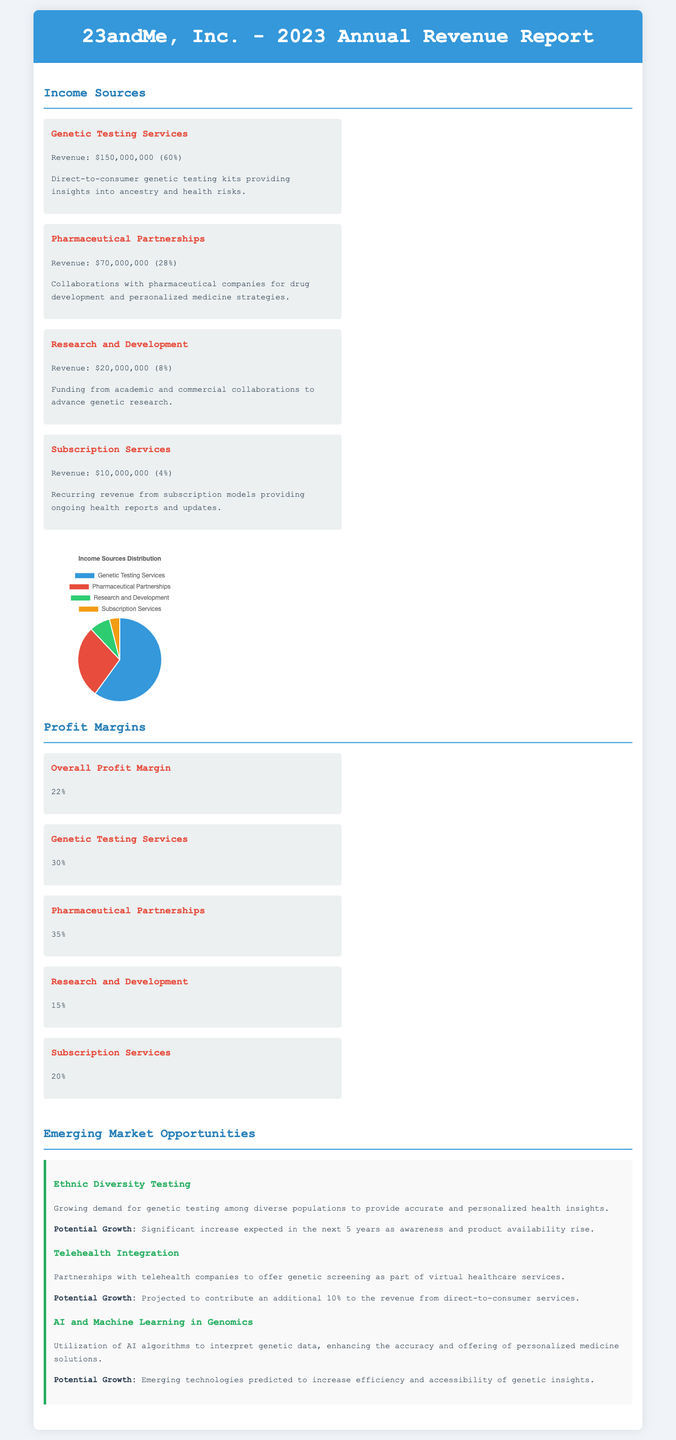what is the revenue from Genetic Testing Services? The revenue for Genetic Testing Services is explicitly stated in the document as $150,000,000.
Answer: $150,000,000 what percentage of the total revenue comes from Pharmaceutical Partnerships? The document specifies that Pharmaceutical Partnerships contribute 28% to the total revenue.
Answer: 28% what is the overall profit margin reported in the document? The overall profit margin is provided as 22%.
Answer: 22% which income source has the highest profit margin? The document states that Pharmaceutical Partnerships have the highest profit margin at 35%.
Answer: 35% what growth potential is mentioned for Telehealth Integration? The document indicates that Telehealth Integration is projected to contribute an additional 10% to the revenue from direct-to-consumer services.
Answer: 10% how much revenue does the Subscription Services generate? The revenue generated from Subscription Services is mentioned as $10,000,000.
Answer: $10,000,000 what emerging market opportunity involves AI and Machine Learning? The document discusses the use of AI and Machine Learning to interpret genetic data for personalized medicine solutions.
Answer: AI and Machine Learning in Genomics what is the expected growth in demand for Ethnic Diversity Testing? The document mentions a significant increase expected in the next 5 years.
Answer: Significant increase what is the revenue from Research and Development collaborations? The document states that Research and Development revenue amounts to $20,000,000.
Answer: $20,000,000 